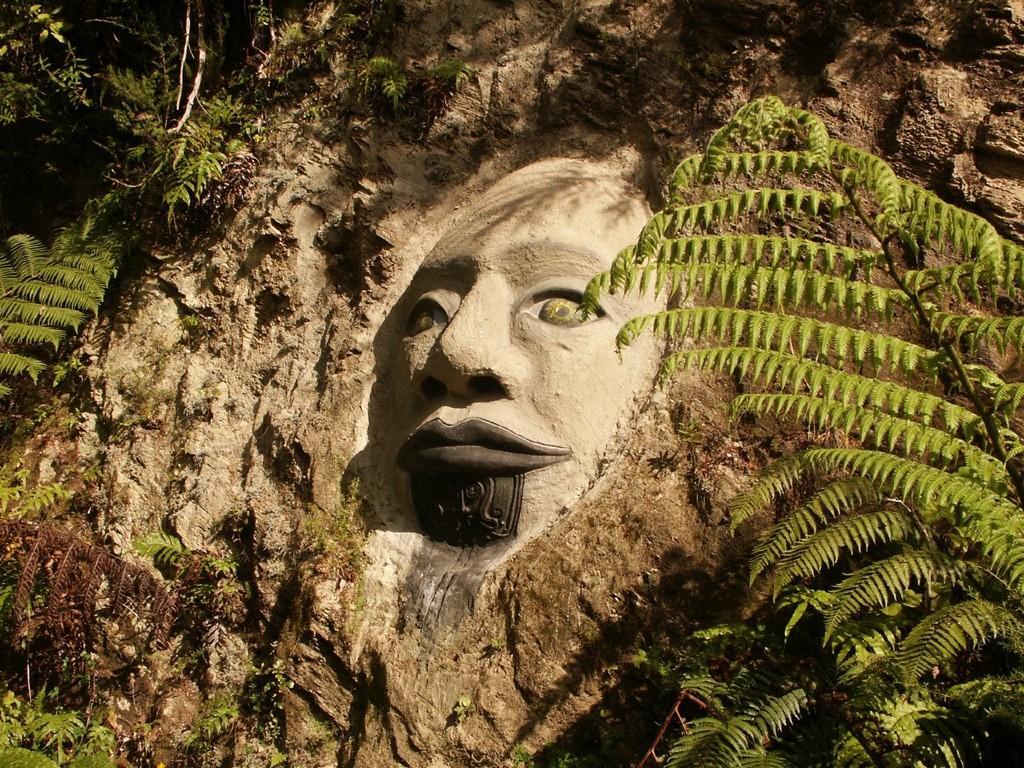Could you give a brief overview of what you see in this image? In this picture I can see there is a sculpture on the mountain and there are plants and trees around it. 